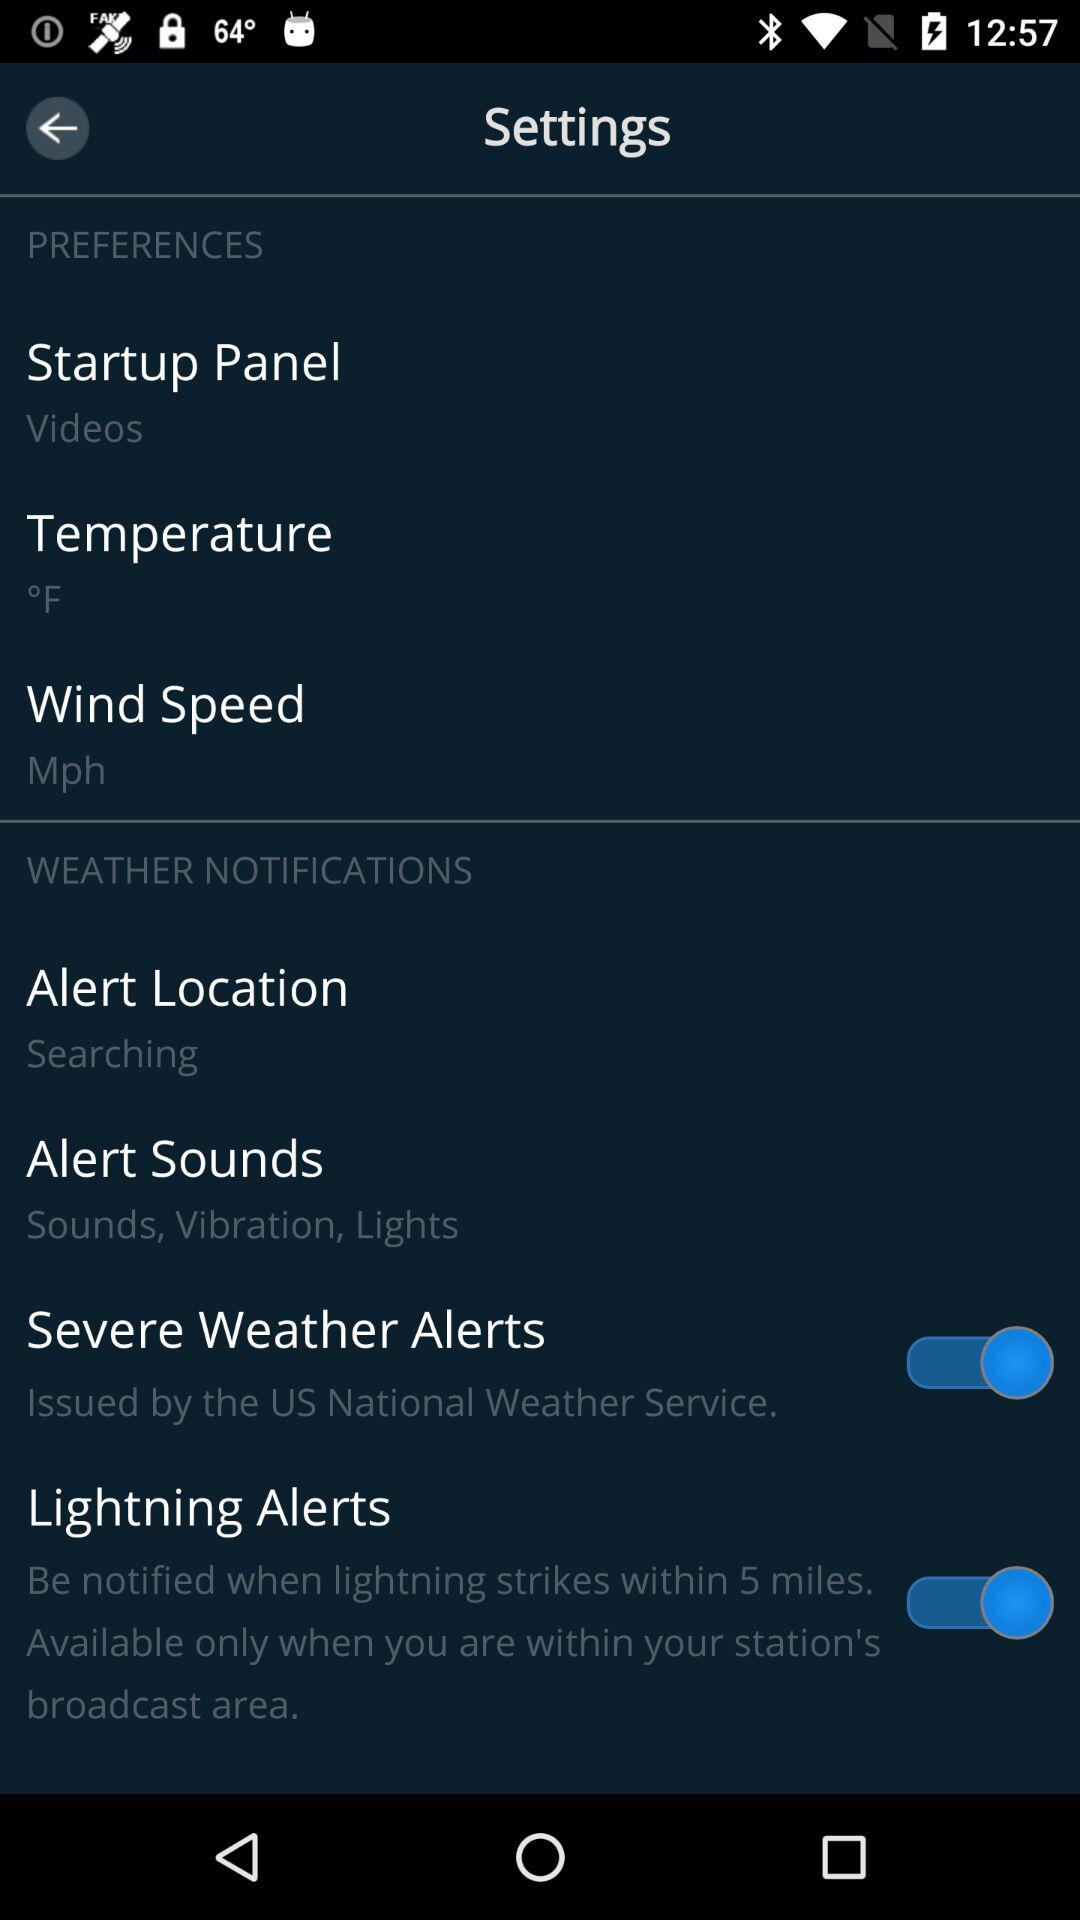What temperature unit is selected? The temperature unit is "°F". 